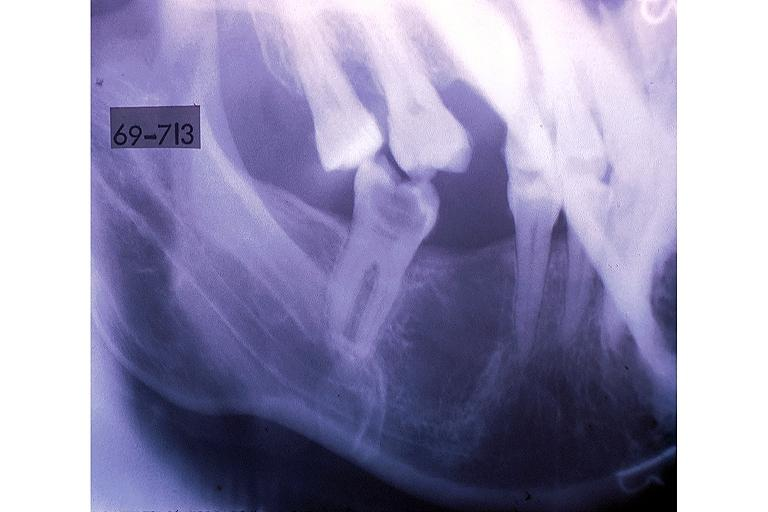what is present?
Answer the question using a single word or phrase. Oral 